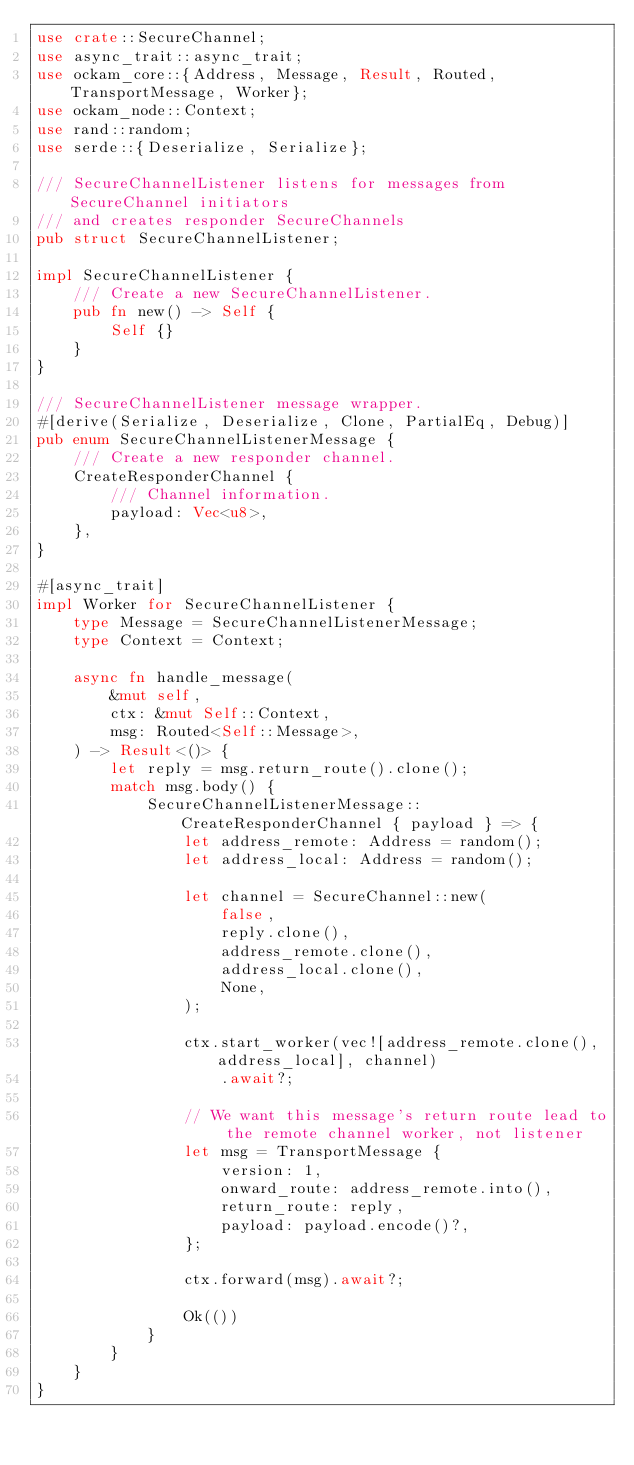<code> <loc_0><loc_0><loc_500><loc_500><_Rust_>use crate::SecureChannel;
use async_trait::async_trait;
use ockam_core::{Address, Message, Result, Routed, TransportMessage, Worker};
use ockam_node::Context;
use rand::random;
use serde::{Deserialize, Serialize};

/// SecureChannelListener listens for messages from SecureChannel initiators
/// and creates responder SecureChannels
pub struct SecureChannelListener;

impl SecureChannelListener {
    /// Create a new SecureChannelListener.
    pub fn new() -> Self {
        Self {}
    }
}

/// SecureChannelListener message wrapper.
#[derive(Serialize, Deserialize, Clone, PartialEq, Debug)]
pub enum SecureChannelListenerMessage {
    /// Create a new responder channel.
    CreateResponderChannel {
        /// Channel information.
        payload: Vec<u8>,
    },
}

#[async_trait]
impl Worker for SecureChannelListener {
    type Message = SecureChannelListenerMessage;
    type Context = Context;

    async fn handle_message(
        &mut self,
        ctx: &mut Self::Context,
        msg: Routed<Self::Message>,
    ) -> Result<()> {
        let reply = msg.return_route().clone();
        match msg.body() {
            SecureChannelListenerMessage::CreateResponderChannel { payload } => {
                let address_remote: Address = random();
                let address_local: Address = random();

                let channel = SecureChannel::new(
                    false,
                    reply.clone(),
                    address_remote.clone(),
                    address_local.clone(),
                    None,
                );

                ctx.start_worker(vec![address_remote.clone(), address_local], channel)
                    .await?;

                // We want this message's return route lead to the remote channel worker, not listener
                let msg = TransportMessage {
                    version: 1,
                    onward_route: address_remote.into(),
                    return_route: reply,
                    payload: payload.encode()?,
                };

                ctx.forward(msg).await?;

                Ok(())
            }
        }
    }
}
</code> 